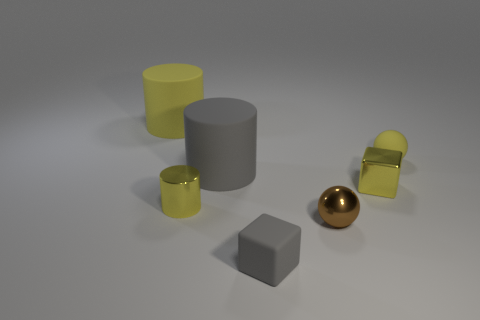Subtract all yellow cylinders. How many cylinders are left? 1 Subtract all yellow cubes. How many yellow cylinders are left? 2 Add 2 small brown balls. How many objects exist? 9 Subtract all purple shiny objects. Subtract all large gray objects. How many objects are left? 6 Add 1 large yellow cylinders. How many large yellow cylinders are left? 2 Add 6 yellow cylinders. How many yellow cylinders exist? 8 Subtract 2 yellow cylinders. How many objects are left? 5 Subtract all cylinders. How many objects are left? 4 Subtract all gray blocks. Subtract all yellow spheres. How many blocks are left? 1 